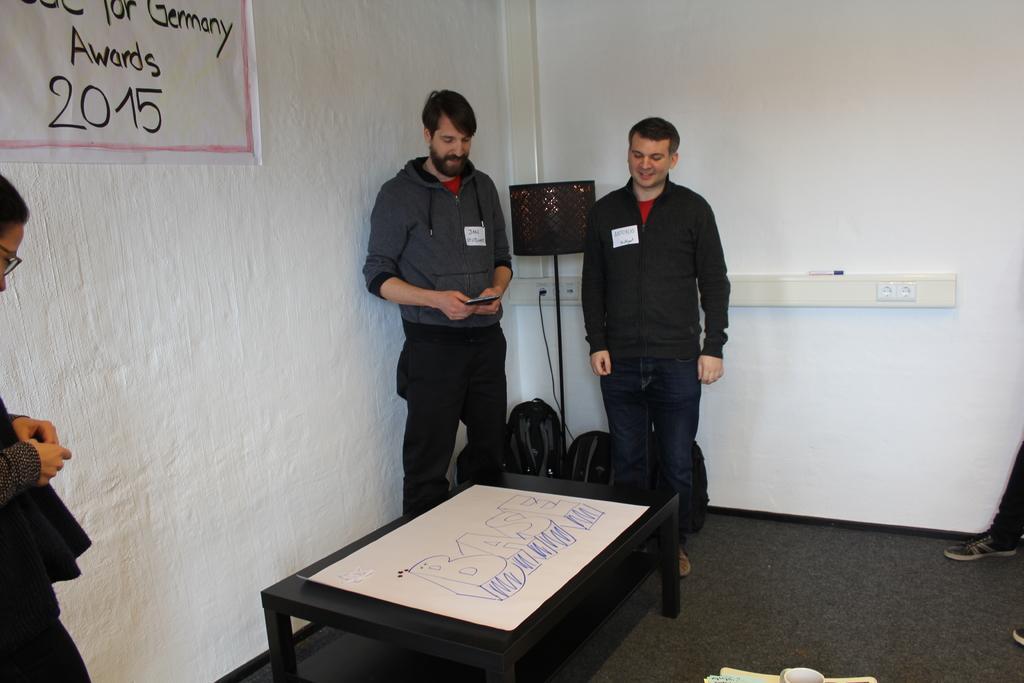Can you describe this image briefly? In this image I can see few people were two of them are men and one is a woman. On this wall I can see a paper where Germany Awards 2015 is written on it. In the background I can see two bags and a table. 